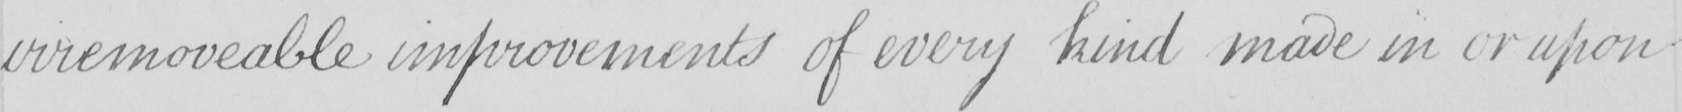Please provide the text content of this handwritten line. irremoveable improvements of every kind made in or upon 